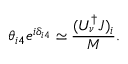<formula> <loc_0><loc_0><loc_500><loc_500>\theta _ { i 4 } e ^ { i \delta _ { i 4 } } \simeq \frac { ( U _ { \nu } ^ { \dagger } J ) _ { i } } { M } .</formula> 